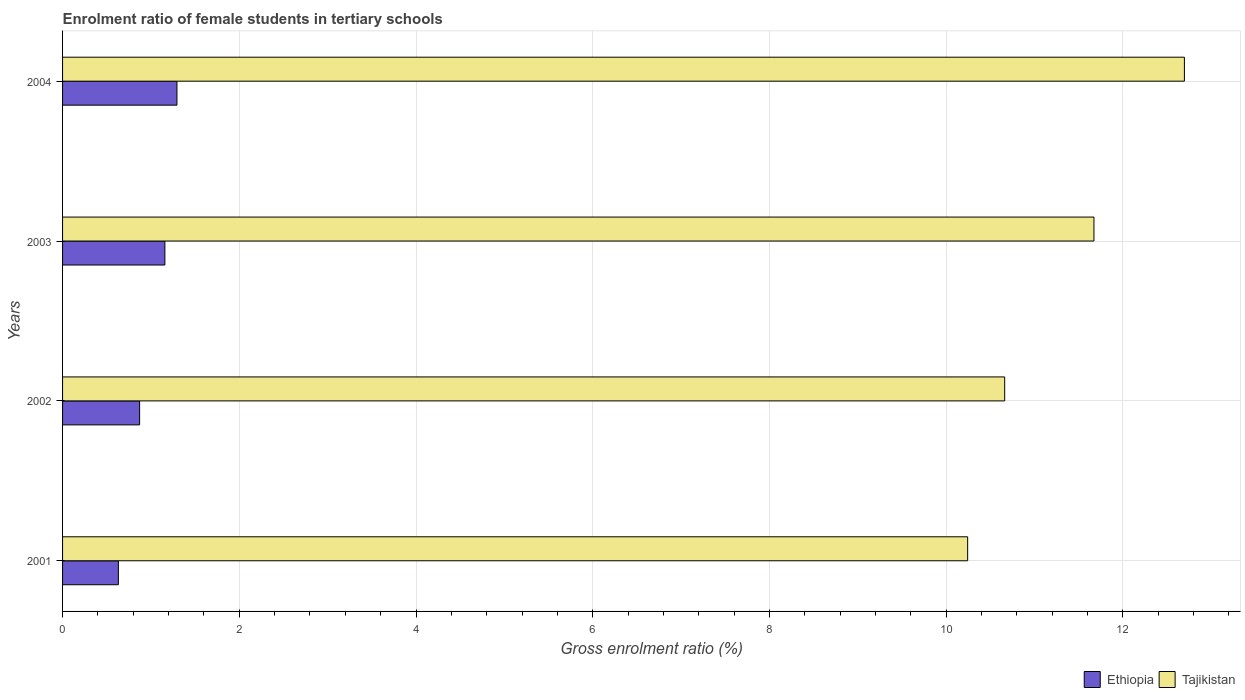How many different coloured bars are there?
Keep it short and to the point. 2. How many groups of bars are there?
Your answer should be very brief. 4. Are the number of bars per tick equal to the number of legend labels?
Your response must be concise. Yes. How many bars are there on the 3rd tick from the bottom?
Make the answer very short. 2. What is the label of the 3rd group of bars from the top?
Keep it short and to the point. 2002. What is the enrolment ratio of female students in tertiary schools in Ethiopia in 2002?
Make the answer very short. 0.87. Across all years, what is the maximum enrolment ratio of female students in tertiary schools in Ethiopia?
Make the answer very short. 1.29. Across all years, what is the minimum enrolment ratio of female students in tertiary schools in Ethiopia?
Ensure brevity in your answer.  0.63. In which year was the enrolment ratio of female students in tertiary schools in Ethiopia minimum?
Keep it short and to the point. 2001. What is the total enrolment ratio of female students in tertiary schools in Tajikistan in the graph?
Your answer should be very brief. 45.28. What is the difference between the enrolment ratio of female students in tertiary schools in Ethiopia in 2001 and that in 2004?
Ensure brevity in your answer.  -0.66. What is the difference between the enrolment ratio of female students in tertiary schools in Tajikistan in 2004 and the enrolment ratio of female students in tertiary schools in Ethiopia in 2003?
Provide a succinct answer. 11.54. What is the average enrolment ratio of female students in tertiary schools in Tajikistan per year?
Your answer should be compact. 11.32. In the year 2003, what is the difference between the enrolment ratio of female students in tertiary schools in Tajikistan and enrolment ratio of female students in tertiary schools in Ethiopia?
Ensure brevity in your answer.  10.52. What is the ratio of the enrolment ratio of female students in tertiary schools in Ethiopia in 2001 to that in 2002?
Keep it short and to the point. 0.72. Is the difference between the enrolment ratio of female students in tertiary schools in Tajikistan in 2003 and 2004 greater than the difference between the enrolment ratio of female students in tertiary schools in Ethiopia in 2003 and 2004?
Give a very brief answer. No. What is the difference between the highest and the second highest enrolment ratio of female students in tertiary schools in Tajikistan?
Your response must be concise. 1.02. What is the difference between the highest and the lowest enrolment ratio of female students in tertiary schools in Ethiopia?
Your answer should be compact. 0.66. Is the sum of the enrolment ratio of female students in tertiary schools in Ethiopia in 2001 and 2003 greater than the maximum enrolment ratio of female students in tertiary schools in Tajikistan across all years?
Your response must be concise. No. What does the 2nd bar from the top in 2003 represents?
Provide a short and direct response. Ethiopia. What does the 2nd bar from the bottom in 2003 represents?
Offer a terse response. Tajikistan. How many bars are there?
Offer a very short reply. 8. Are all the bars in the graph horizontal?
Offer a terse response. Yes. Are the values on the major ticks of X-axis written in scientific E-notation?
Ensure brevity in your answer.  No. Does the graph contain grids?
Make the answer very short. Yes. What is the title of the graph?
Offer a terse response. Enrolment ratio of female students in tertiary schools. Does "Mexico" appear as one of the legend labels in the graph?
Provide a short and direct response. No. What is the label or title of the Y-axis?
Give a very brief answer. Years. What is the Gross enrolment ratio (%) of Ethiopia in 2001?
Provide a short and direct response. 0.63. What is the Gross enrolment ratio (%) of Tajikistan in 2001?
Your answer should be very brief. 10.24. What is the Gross enrolment ratio (%) of Ethiopia in 2002?
Your answer should be very brief. 0.87. What is the Gross enrolment ratio (%) of Tajikistan in 2002?
Ensure brevity in your answer.  10.66. What is the Gross enrolment ratio (%) of Ethiopia in 2003?
Provide a succinct answer. 1.16. What is the Gross enrolment ratio (%) in Tajikistan in 2003?
Keep it short and to the point. 11.67. What is the Gross enrolment ratio (%) in Ethiopia in 2004?
Your response must be concise. 1.29. What is the Gross enrolment ratio (%) of Tajikistan in 2004?
Your answer should be very brief. 12.7. Across all years, what is the maximum Gross enrolment ratio (%) in Ethiopia?
Offer a terse response. 1.29. Across all years, what is the maximum Gross enrolment ratio (%) in Tajikistan?
Provide a succinct answer. 12.7. Across all years, what is the minimum Gross enrolment ratio (%) of Ethiopia?
Offer a very short reply. 0.63. Across all years, what is the minimum Gross enrolment ratio (%) of Tajikistan?
Give a very brief answer. 10.24. What is the total Gross enrolment ratio (%) in Ethiopia in the graph?
Your answer should be very brief. 3.96. What is the total Gross enrolment ratio (%) in Tajikistan in the graph?
Provide a succinct answer. 45.28. What is the difference between the Gross enrolment ratio (%) of Ethiopia in 2001 and that in 2002?
Make the answer very short. -0.24. What is the difference between the Gross enrolment ratio (%) in Tajikistan in 2001 and that in 2002?
Give a very brief answer. -0.42. What is the difference between the Gross enrolment ratio (%) of Ethiopia in 2001 and that in 2003?
Your answer should be compact. -0.53. What is the difference between the Gross enrolment ratio (%) of Tajikistan in 2001 and that in 2003?
Your response must be concise. -1.43. What is the difference between the Gross enrolment ratio (%) in Ethiopia in 2001 and that in 2004?
Your answer should be compact. -0.66. What is the difference between the Gross enrolment ratio (%) in Tajikistan in 2001 and that in 2004?
Offer a very short reply. -2.45. What is the difference between the Gross enrolment ratio (%) of Ethiopia in 2002 and that in 2003?
Offer a very short reply. -0.29. What is the difference between the Gross enrolment ratio (%) of Tajikistan in 2002 and that in 2003?
Provide a short and direct response. -1.01. What is the difference between the Gross enrolment ratio (%) in Ethiopia in 2002 and that in 2004?
Your response must be concise. -0.42. What is the difference between the Gross enrolment ratio (%) in Tajikistan in 2002 and that in 2004?
Your response must be concise. -2.03. What is the difference between the Gross enrolment ratio (%) of Ethiopia in 2003 and that in 2004?
Provide a short and direct response. -0.14. What is the difference between the Gross enrolment ratio (%) of Tajikistan in 2003 and that in 2004?
Your response must be concise. -1.02. What is the difference between the Gross enrolment ratio (%) of Ethiopia in 2001 and the Gross enrolment ratio (%) of Tajikistan in 2002?
Give a very brief answer. -10.03. What is the difference between the Gross enrolment ratio (%) of Ethiopia in 2001 and the Gross enrolment ratio (%) of Tajikistan in 2003?
Provide a succinct answer. -11.04. What is the difference between the Gross enrolment ratio (%) in Ethiopia in 2001 and the Gross enrolment ratio (%) in Tajikistan in 2004?
Your response must be concise. -12.06. What is the difference between the Gross enrolment ratio (%) of Ethiopia in 2002 and the Gross enrolment ratio (%) of Tajikistan in 2003?
Your response must be concise. -10.8. What is the difference between the Gross enrolment ratio (%) of Ethiopia in 2002 and the Gross enrolment ratio (%) of Tajikistan in 2004?
Offer a very short reply. -11.82. What is the difference between the Gross enrolment ratio (%) of Ethiopia in 2003 and the Gross enrolment ratio (%) of Tajikistan in 2004?
Ensure brevity in your answer.  -11.54. What is the average Gross enrolment ratio (%) in Tajikistan per year?
Your answer should be very brief. 11.32. In the year 2001, what is the difference between the Gross enrolment ratio (%) in Ethiopia and Gross enrolment ratio (%) in Tajikistan?
Provide a succinct answer. -9.61. In the year 2002, what is the difference between the Gross enrolment ratio (%) in Ethiopia and Gross enrolment ratio (%) in Tajikistan?
Your answer should be compact. -9.79. In the year 2003, what is the difference between the Gross enrolment ratio (%) of Ethiopia and Gross enrolment ratio (%) of Tajikistan?
Provide a short and direct response. -10.52. In the year 2004, what is the difference between the Gross enrolment ratio (%) in Ethiopia and Gross enrolment ratio (%) in Tajikistan?
Your answer should be very brief. -11.4. What is the ratio of the Gross enrolment ratio (%) of Ethiopia in 2001 to that in 2002?
Give a very brief answer. 0.72. What is the ratio of the Gross enrolment ratio (%) of Tajikistan in 2001 to that in 2002?
Ensure brevity in your answer.  0.96. What is the ratio of the Gross enrolment ratio (%) in Ethiopia in 2001 to that in 2003?
Provide a short and direct response. 0.55. What is the ratio of the Gross enrolment ratio (%) in Tajikistan in 2001 to that in 2003?
Your answer should be compact. 0.88. What is the ratio of the Gross enrolment ratio (%) of Ethiopia in 2001 to that in 2004?
Ensure brevity in your answer.  0.49. What is the ratio of the Gross enrolment ratio (%) of Tajikistan in 2001 to that in 2004?
Keep it short and to the point. 0.81. What is the ratio of the Gross enrolment ratio (%) of Ethiopia in 2002 to that in 2003?
Your response must be concise. 0.75. What is the ratio of the Gross enrolment ratio (%) in Tajikistan in 2002 to that in 2003?
Provide a succinct answer. 0.91. What is the ratio of the Gross enrolment ratio (%) in Ethiopia in 2002 to that in 2004?
Your answer should be compact. 0.67. What is the ratio of the Gross enrolment ratio (%) of Tajikistan in 2002 to that in 2004?
Your answer should be compact. 0.84. What is the ratio of the Gross enrolment ratio (%) of Ethiopia in 2003 to that in 2004?
Keep it short and to the point. 0.89. What is the ratio of the Gross enrolment ratio (%) of Tajikistan in 2003 to that in 2004?
Provide a succinct answer. 0.92. What is the difference between the highest and the second highest Gross enrolment ratio (%) of Ethiopia?
Your response must be concise. 0.14. What is the difference between the highest and the second highest Gross enrolment ratio (%) of Tajikistan?
Your response must be concise. 1.02. What is the difference between the highest and the lowest Gross enrolment ratio (%) of Ethiopia?
Offer a very short reply. 0.66. What is the difference between the highest and the lowest Gross enrolment ratio (%) of Tajikistan?
Your answer should be compact. 2.45. 